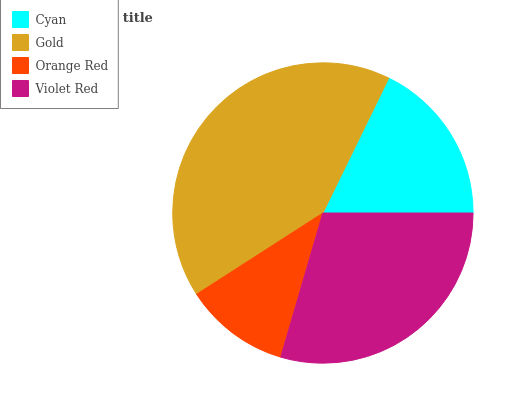Is Orange Red the minimum?
Answer yes or no. Yes. Is Gold the maximum?
Answer yes or no. Yes. Is Gold the minimum?
Answer yes or no. No. Is Orange Red the maximum?
Answer yes or no. No. Is Gold greater than Orange Red?
Answer yes or no. Yes. Is Orange Red less than Gold?
Answer yes or no. Yes. Is Orange Red greater than Gold?
Answer yes or no. No. Is Gold less than Orange Red?
Answer yes or no. No. Is Violet Red the high median?
Answer yes or no. Yes. Is Cyan the low median?
Answer yes or no. Yes. Is Gold the high median?
Answer yes or no. No. Is Orange Red the low median?
Answer yes or no. No. 